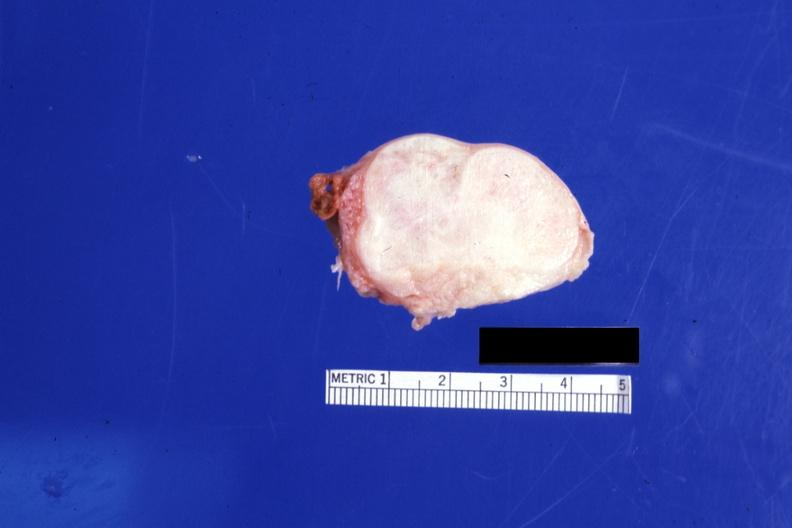s good example of muscle atrophy present?
Answer the question using a single word or phrase. No 